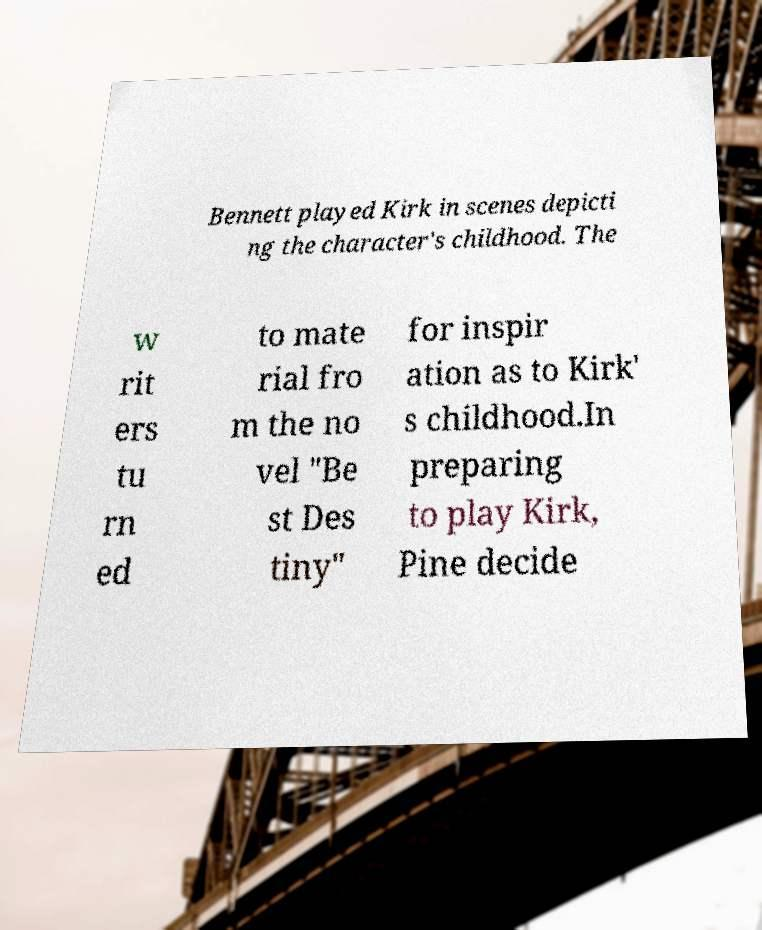Please identify and transcribe the text found in this image. Bennett played Kirk in scenes depicti ng the character's childhood. The w rit ers tu rn ed to mate rial fro m the no vel "Be st Des tiny" for inspir ation as to Kirk' s childhood.In preparing to play Kirk, Pine decide 